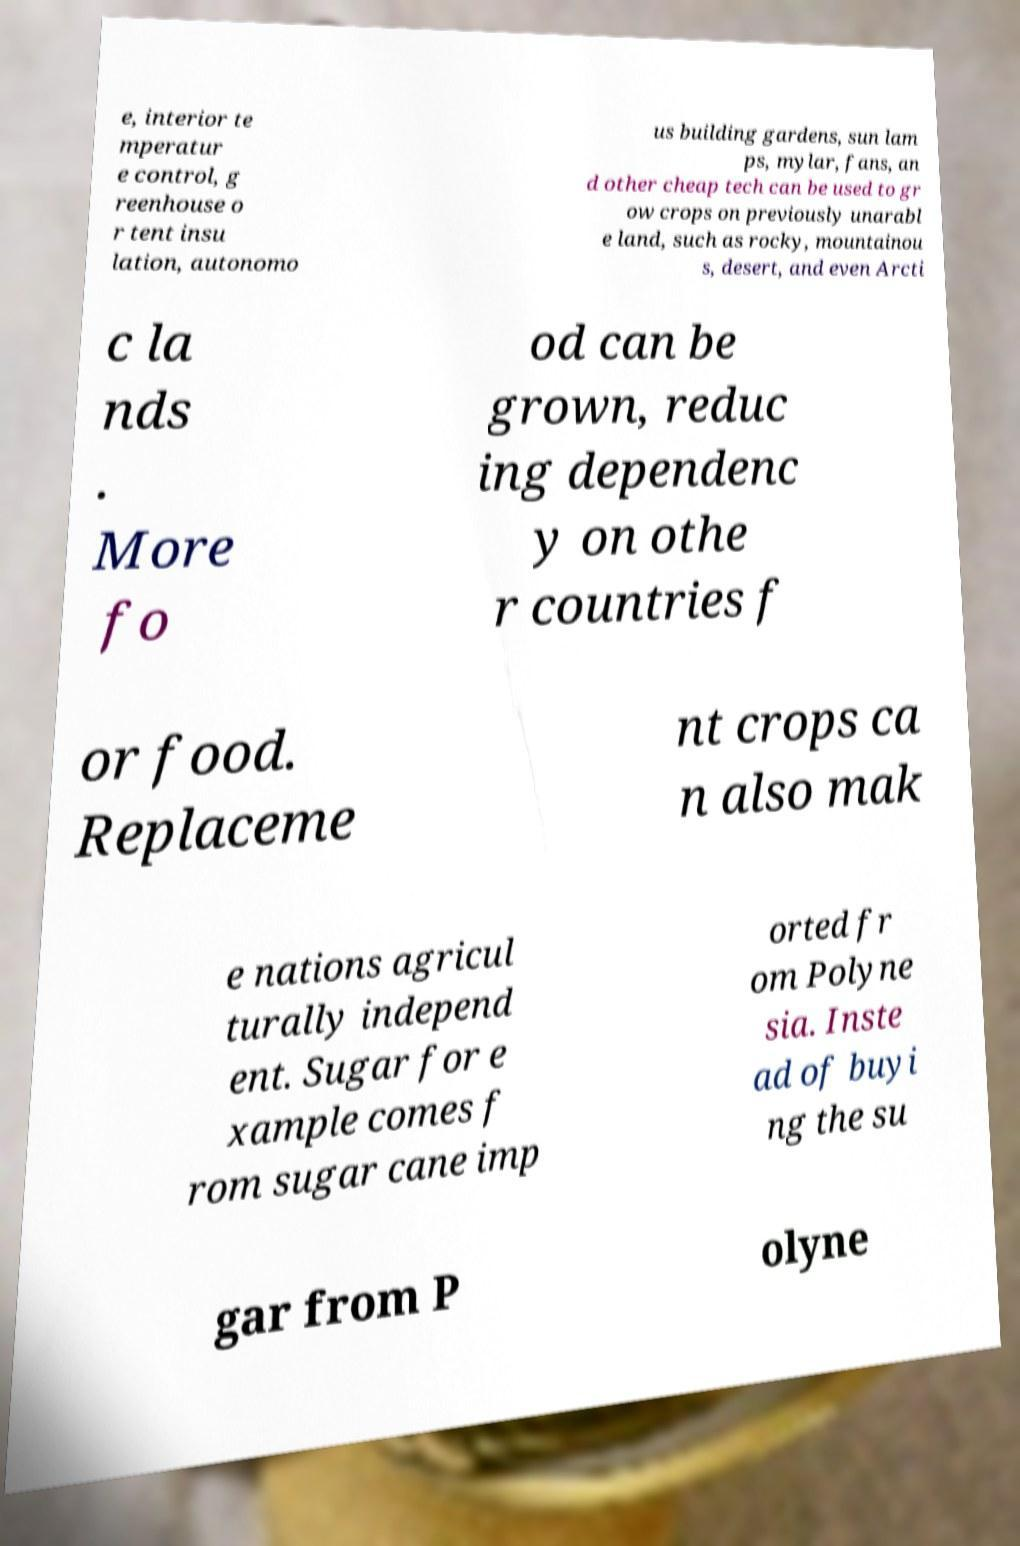Can you read and provide the text displayed in the image?This photo seems to have some interesting text. Can you extract and type it out for me? e, interior te mperatur e control, g reenhouse o r tent insu lation, autonomo us building gardens, sun lam ps, mylar, fans, an d other cheap tech can be used to gr ow crops on previously unarabl e land, such as rocky, mountainou s, desert, and even Arcti c la nds . More fo od can be grown, reduc ing dependenc y on othe r countries f or food. Replaceme nt crops ca n also mak e nations agricul turally independ ent. Sugar for e xample comes f rom sugar cane imp orted fr om Polyne sia. Inste ad of buyi ng the su gar from P olyne 